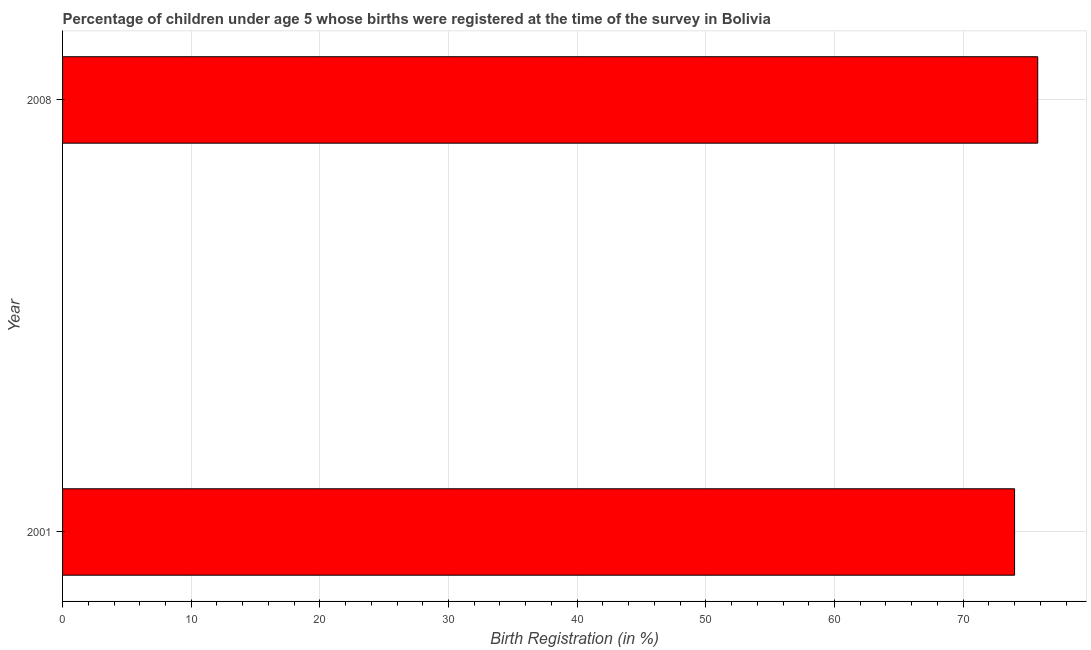Does the graph contain any zero values?
Your answer should be compact. No. Does the graph contain grids?
Provide a succinct answer. Yes. What is the title of the graph?
Provide a short and direct response. Percentage of children under age 5 whose births were registered at the time of the survey in Bolivia. What is the label or title of the X-axis?
Provide a short and direct response. Birth Registration (in %). What is the label or title of the Y-axis?
Keep it short and to the point. Year. What is the birth registration in 2008?
Your response must be concise. 75.8. Across all years, what is the maximum birth registration?
Give a very brief answer. 75.8. Across all years, what is the minimum birth registration?
Your answer should be very brief. 74. In which year was the birth registration minimum?
Provide a succinct answer. 2001. What is the sum of the birth registration?
Your response must be concise. 149.8. What is the average birth registration per year?
Offer a terse response. 74.9. What is the median birth registration?
Offer a very short reply. 74.9. Do a majority of the years between 2008 and 2001 (inclusive) have birth registration greater than 32 %?
Keep it short and to the point. No. How many bars are there?
Provide a short and direct response. 2. How many years are there in the graph?
Your response must be concise. 2. What is the Birth Registration (in %) in 2008?
Make the answer very short. 75.8. What is the difference between the Birth Registration (in %) in 2001 and 2008?
Offer a very short reply. -1.8. 